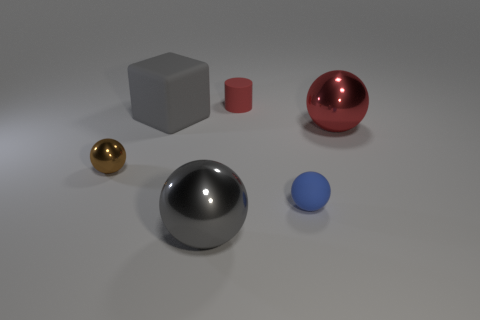Add 2 large gray metal cylinders. How many objects exist? 8 Subtract all cylinders. How many objects are left? 5 Add 4 matte cylinders. How many matte cylinders exist? 5 Subtract 0 cyan balls. How many objects are left? 6 Subtract all large rubber things. Subtract all big red shiny things. How many objects are left? 4 Add 5 large rubber cubes. How many large rubber cubes are left? 6 